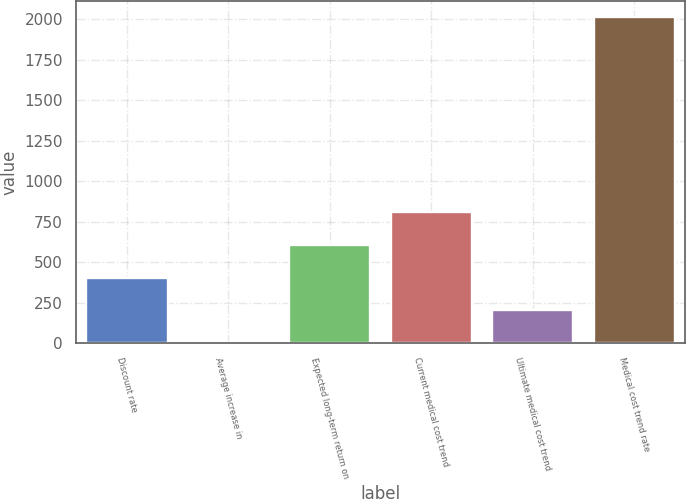Convert chart. <chart><loc_0><loc_0><loc_500><loc_500><bar_chart><fcel>Discount rate<fcel>Average increase in<fcel>Expected long-term return on<fcel>Current medical cost trend<fcel>Ultimate medical cost trend<fcel>Medical cost trend rate<nl><fcel>405.4<fcel>3.5<fcel>606.35<fcel>807.3<fcel>204.45<fcel>2013<nl></chart> 